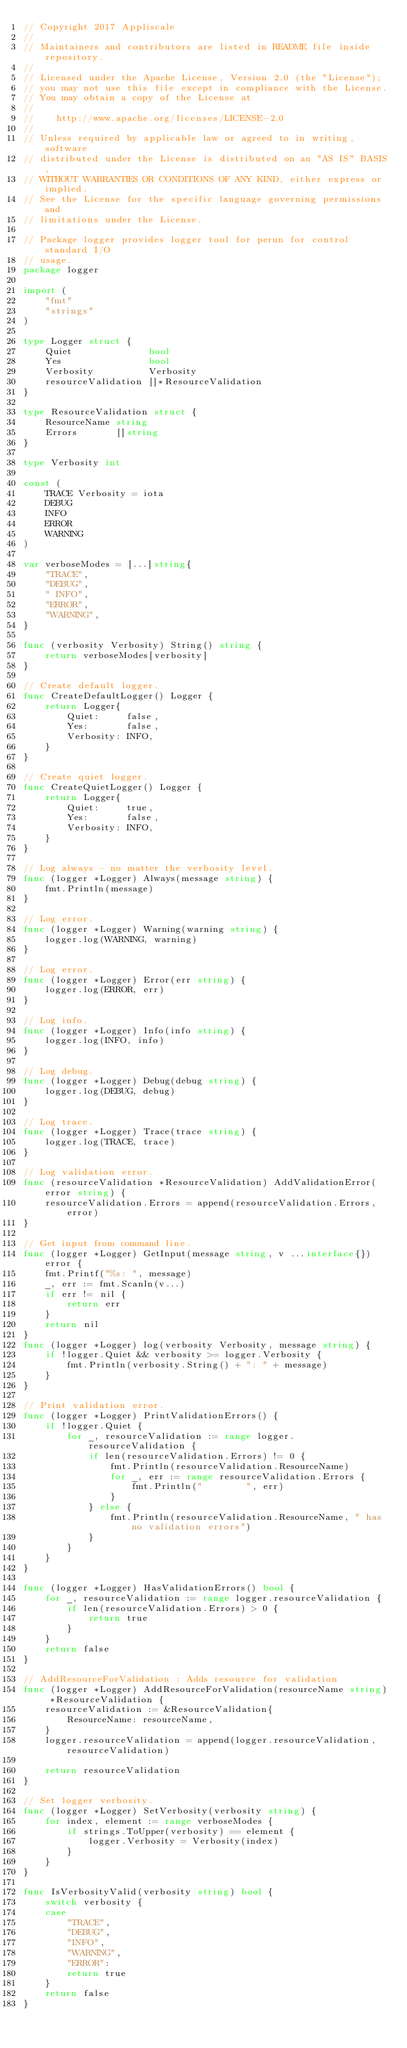Convert code to text. <code><loc_0><loc_0><loc_500><loc_500><_Go_>// Copyright 2017 Appliscale
//
// Maintainers and contributors are listed in README file inside repository.
//
// Licensed under the Apache License, Version 2.0 (the "License");
// you may not use this file except in compliance with the License.
// You may obtain a copy of the License at
//
//    http://www.apache.org/licenses/LICENSE-2.0
//
// Unless required by applicable law or agreed to in writing, software
// distributed under the License is distributed on an "AS IS" BASIS,
// WITHOUT WARRANTIES OR CONDITIONS OF ANY KIND, either express or implied.
// See the License for the specific language governing permissions and
// limitations under the License.

// Package logger provides logger tool for perun for control standard I/O
// usage.
package logger

import (
	"fmt"
	"strings"
)

type Logger struct {
	Quiet              bool
	Yes                bool
	Verbosity          Verbosity
	resourceValidation []*ResourceValidation
}

type ResourceValidation struct {
	ResourceName string
	Errors       []string
}

type Verbosity int

const (
	TRACE Verbosity = iota
	DEBUG
	INFO
	ERROR
	WARNING
)

var verboseModes = [...]string{
	"TRACE",
	"DEBUG",
	" INFO",
	"ERROR",
	"WARNING",
}

func (verbosity Verbosity) String() string {
	return verboseModes[verbosity]
}

// Create default logger.
func CreateDefaultLogger() Logger {
	return Logger{
		Quiet:     false,
		Yes:       false,
		Verbosity: INFO,
	}
}

// Create quiet logger.
func CreateQuietLogger() Logger {
	return Logger{
		Quiet:     true,
		Yes:       false,
		Verbosity: INFO,
	}
}

// Log always - no matter the verbosity level.
func (logger *Logger) Always(message string) {
	fmt.Println(message)
}

// Log error.
func (logger *Logger) Warning(warning string) {
	logger.log(WARNING, warning)
}

// Log error.
func (logger *Logger) Error(err string) {
	logger.log(ERROR, err)
}

// Log info.
func (logger *Logger) Info(info string) {
	logger.log(INFO, info)
}

// Log debug.
func (logger *Logger) Debug(debug string) {
	logger.log(DEBUG, debug)
}

// Log trace.
func (logger *Logger) Trace(trace string) {
	logger.log(TRACE, trace)
}

// Log validation error.
func (resourceValidation *ResourceValidation) AddValidationError(error string) {
	resourceValidation.Errors = append(resourceValidation.Errors, error)
}

// Get input from command line.
func (logger *Logger) GetInput(message string, v ...interface{}) error {
	fmt.Printf("%s: ", message)
	_, err := fmt.Scanln(v...)
	if err != nil {
		return err
	}
	return nil
}
func (logger *Logger) log(verbosity Verbosity, message string) {
	if !logger.Quiet && verbosity >= logger.Verbosity {
		fmt.Println(verbosity.String() + ": " + message)
	}
}

// Print validation error.
func (logger *Logger) PrintValidationErrors() {
	if !logger.Quiet {
		for _, resourceValidation := range logger.resourceValidation {
			if len(resourceValidation.Errors) != 0 {
				fmt.Println(resourceValidation.ResourceName)
				for _, err := range resourceValidation.Errors {
					fmt.Println("        ", err)
				}
			} else {
				fmt.Println(resourceValidation.ResourceName, " has no validation errors")
			}
		}
	}
}

func (logger *Logger) HasValidationErrors() bool {
	for _, resourceValidation := range logger.resourceValidation {
		if len(resourceValidation.Errors) > 0 {
			return true
		}
	}
	return false
}

// AddResourceForValidation : Adds resource for validation
func (logger *Logger) AddResourceForValidation(resourceName string) *ResourceValidation {
	resourceValidation := &ResourceValidation{
		ResourceName: resourceName,
	}
	logger.resourceValidation = append(logger.resourceValidation, resourceValidation)

	return resourceValidation
}

// Set logger verbosity.
func (logger *Logger) SetVerbosity(verbosity string) {
	for index, element := range verboseModes {
		if strings.ToUpper(verbosity) == element {
			logger.Verbosity = Verbosity(index)
		}
	}
}

func IsVerbosityValid(verbosity string) bool {
	switch verbosity {
	case
		"TRACE",
		"DEBUG",
		"INFO",
		"WARNING",
		"ERROR":
		return true
	}
	return false
}
</code> 